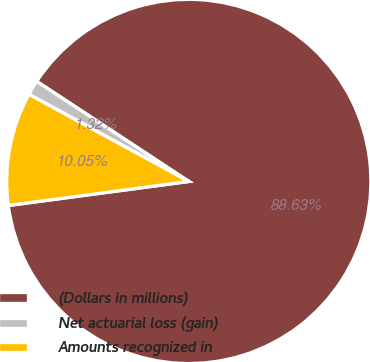Convert chart to OTSL. <chart><loc_0><loc_0><loc_500><loc_500><pie_chart><fcel>(Dollars in millions)<fcel>Net actuarial loss (gain)<fcel>Amounts recognized in<nl><fcel>88.63%<fcel>1.32%<fcel>10.05%<nl></chart> 